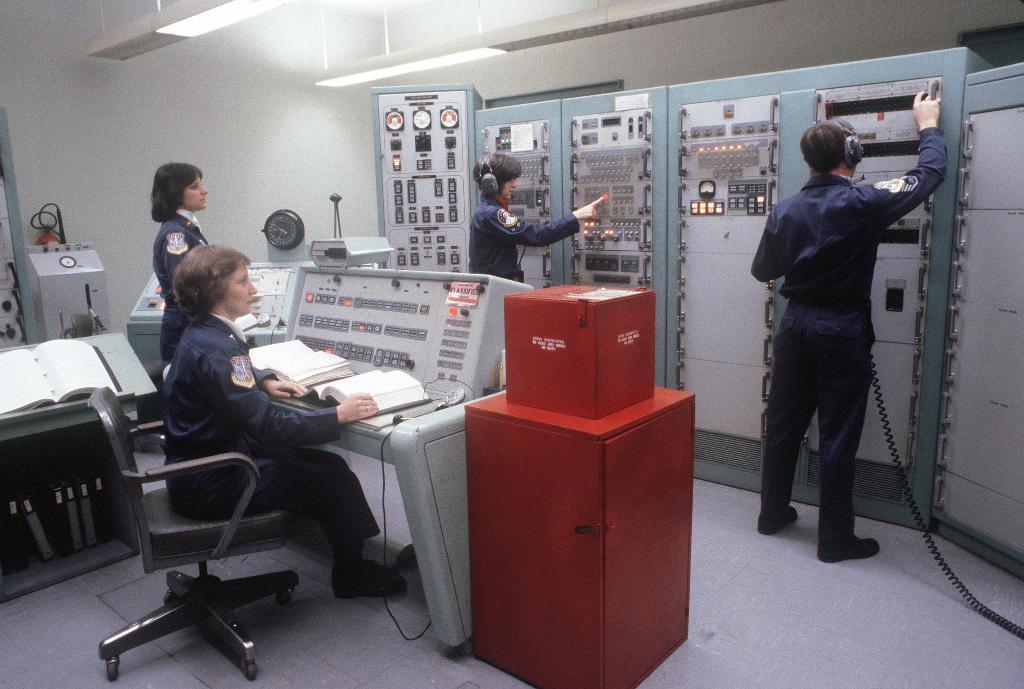Could you give a brief overview of what you see in this image? There are four persons in a operating room. All of them are wearing blue uniform. Three of them are standing,one of them is sitting in a chair. These two people are working on a machine wearing a headsets. There are group of files and there are three books are open. There are two lights in a room. 